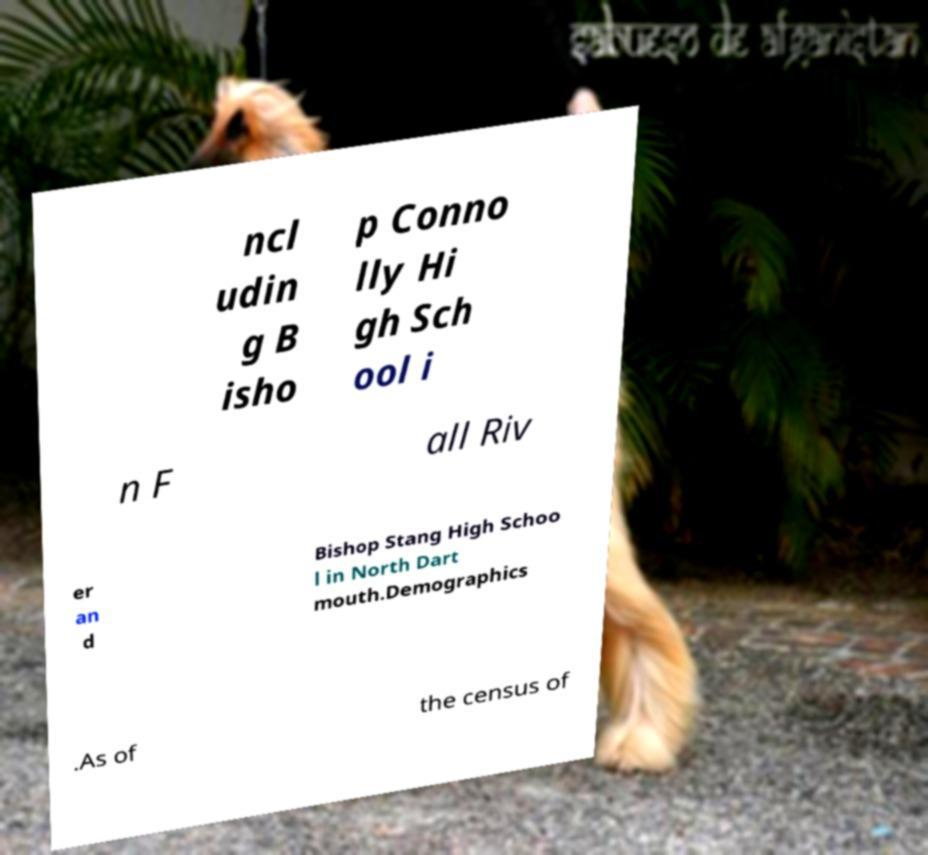Can you accurately transcribe the text from the provided image for me? ncl udin g B isho p Conno lly Hi gh Sch ool i n F all Riv er an d Bishop Stang High Schoo l in North Dart mouth.Demographics .As of the census of 